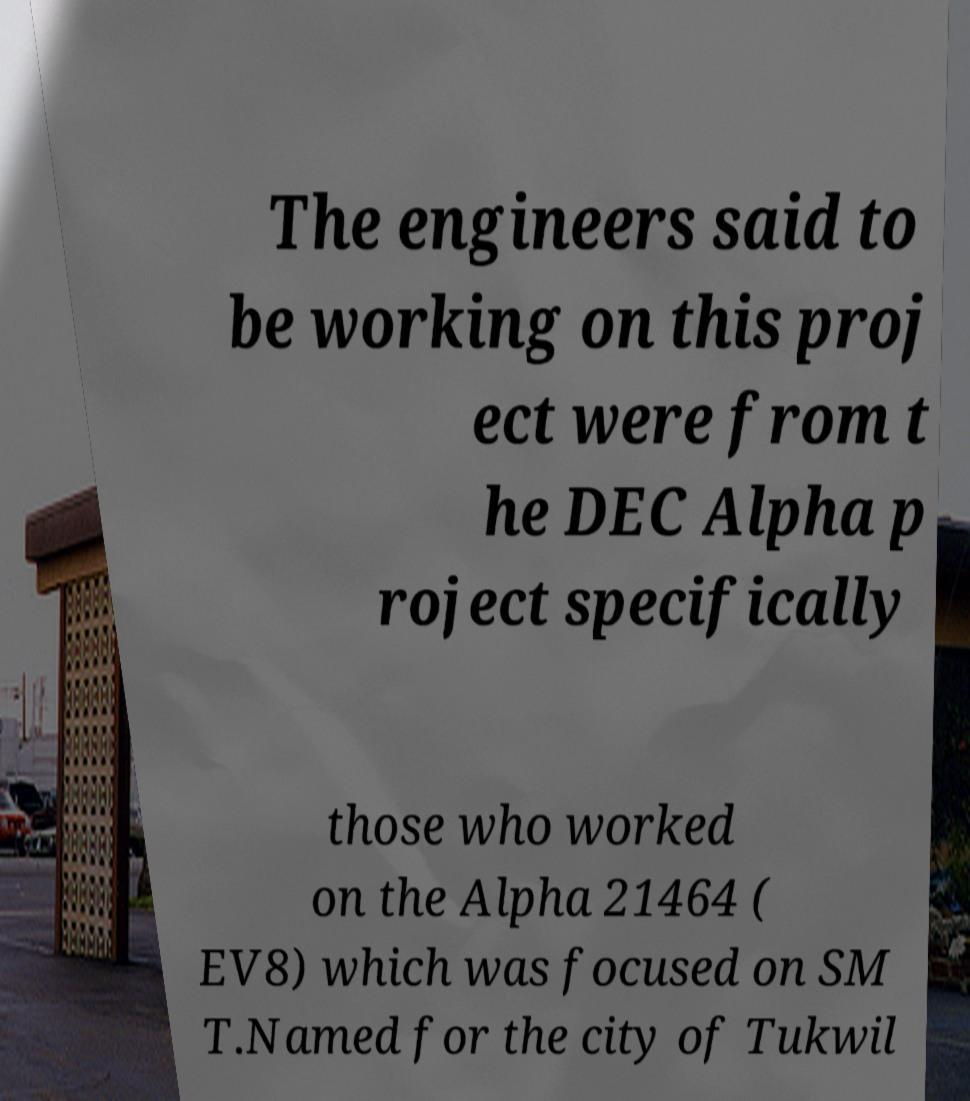Please identify and transcribe the text found in this image. The engineers said to be working on this proj ect were from t he DEC Alpha p roject specifically those who worked on the Alpha 21464 ( EV8) which was focused on SM T.Named for the city of Tukwil 